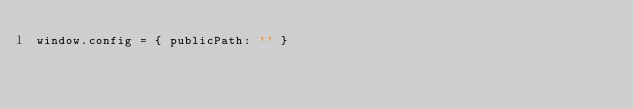Convert code to text. <code><loc_0><loc_0><loc_500><loc_500><_JavaScript_>window.config = { publicPath: '' }
</code> 